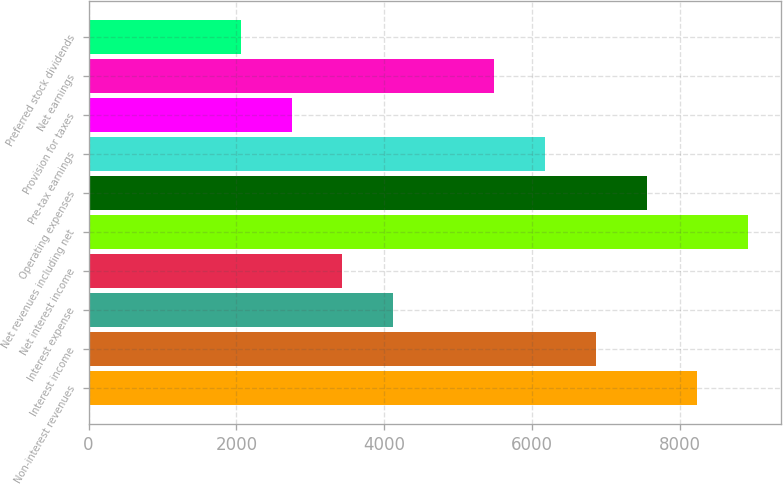Convert chart. <chart><loc_0><loc_0><loc_500><loc_500><bar_chart><fcel>Non-interest revenues<fcel>Interest income<fcel>Interest expense<fcel>Net interest income<fcel>Net revenues including net<fcel>Operating expenses<fcel>Pre-tax earnings<fcel>Provision for taxes<fcel>Net earnings<fcel>Preferred stock dividends<nl><fcel>8233.12<fcel>6861.05<fcel>4116.89<fcel>3430.85<fcel>8919.16<fcel>7547.09<fcel>6175.01<fcel>2744.81<fcel>5488.97<fcel>2058.77<nl></chart> 